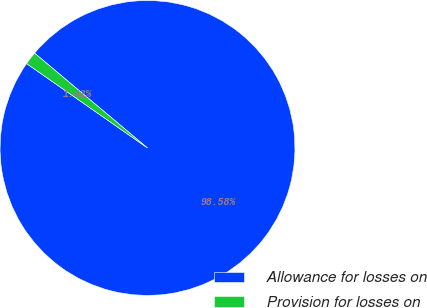Convert chart to OTSL. <chart><loc_0><loc_0><loc_500><loc_500><pie_chart><fcel>Allowance for losses on<fcel>Provision for losses on<nl><fcel>98.58%<fcel>1.42%<nl></chart> 